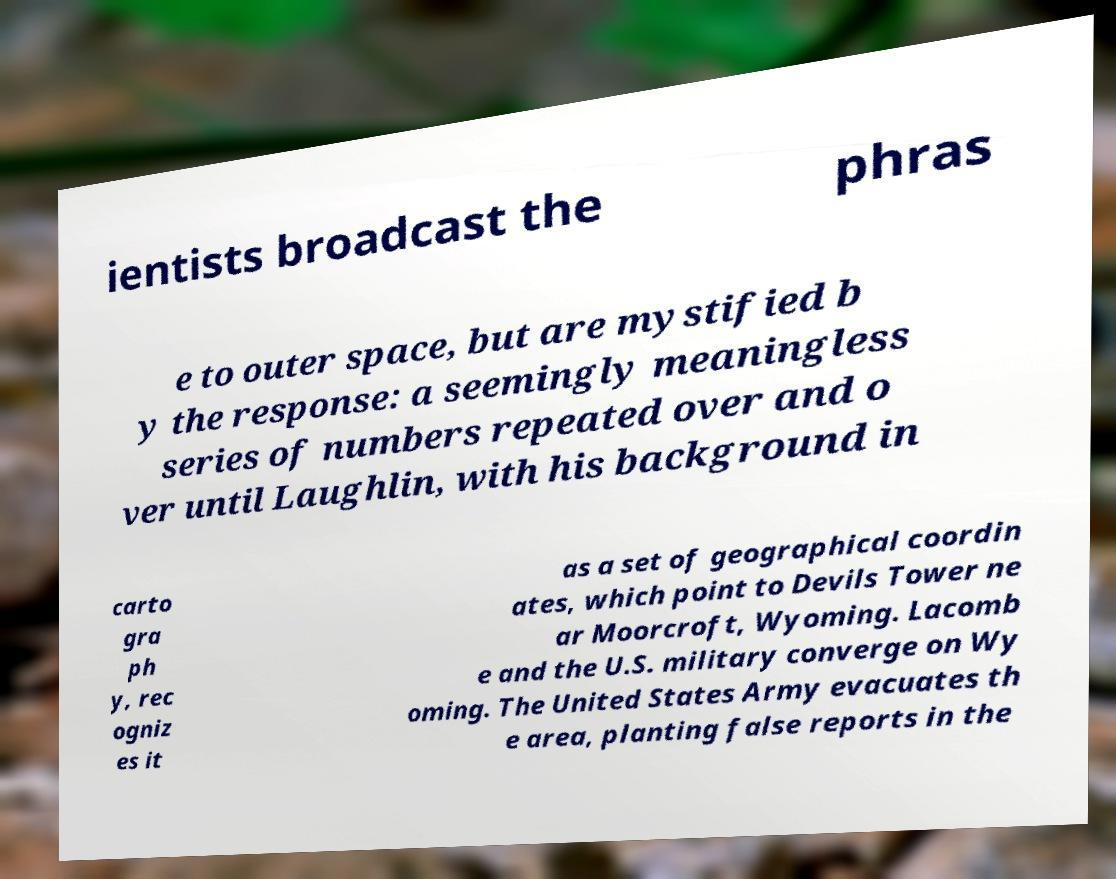Can you accurately transcribe the text from the provided image for me? ientists broadcast the phras e to outer space, but are mystified b y the response: a seemingly meaningless series of numbers repeated over and o ver until Laughlin, with his background in carto gra ph y, rec ogniz es it as a set of geographical coordin ates, which point to Devils Tower ne ar Moorcroft, Wyoming. Lacomb e and the U.S. military converge on Wy oming. The United States Army evacuates th e area, planting false reports in the 